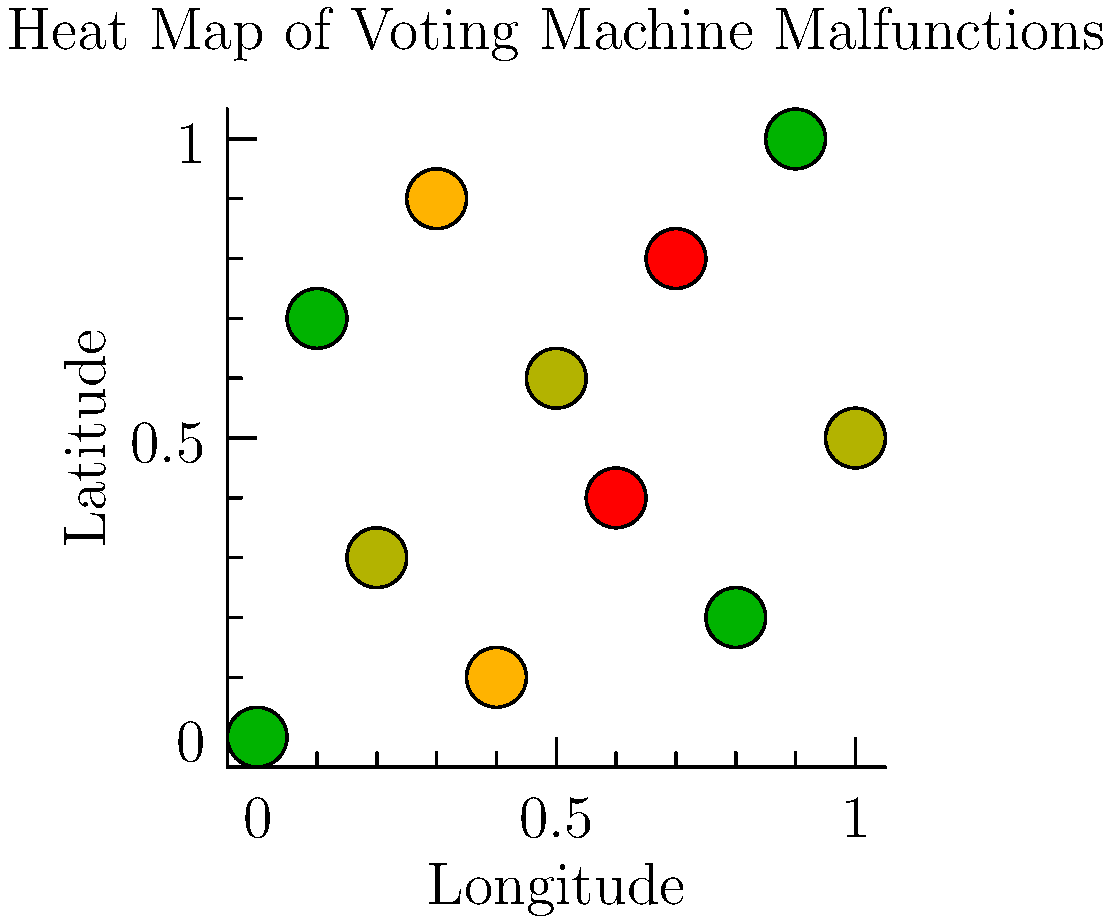Based on the heat map showing the distribution of voting machine malfunctions across polling stations, which quadrant of the map appears to have the highest concentration of severe malfunctions (represented by red dots)? Consider the map divided into four equal quadrants. To answer this question, we need to follow these steps:

1. Understand the heat map:
   - The map represents polling stations across a geographic area.
   - The color of each dot represents the severity of malfunctions:
     Green: Low severity
     Yellow: Moderate severity
     Orange: High severity
     Red: Severe malfunctions

2. Divide the map into four quadrants:
   - Imagine the map divided into four equal parts: top-left, top-right, bottom-left, and bottom-right.

3. Analyze the distribution of red dots (severe malfunctions):
   - Top-left quadrant: No red dots
   - Top-right quadrant: One red dot
   - Bottom-left quadrant: No red dots
   - Bottom-right quadrant: One red dot

4. Compare the concentration of severe malfunctions:
   - The top-right and bottom-right quadrants both have one red dot.
   - However, the top-right quadrant has its red dot closer to the center, potentially indicating a higher concentration.

5. Consider the overall distribution of high-severity dots (orange and red):
   - The top-right quadrant has more high-severity dots clustered together.

Based on this analysis, the top-right quadrant appears to have the highest concentration of severe malfunctions.
Answer: Top-right quadrant 